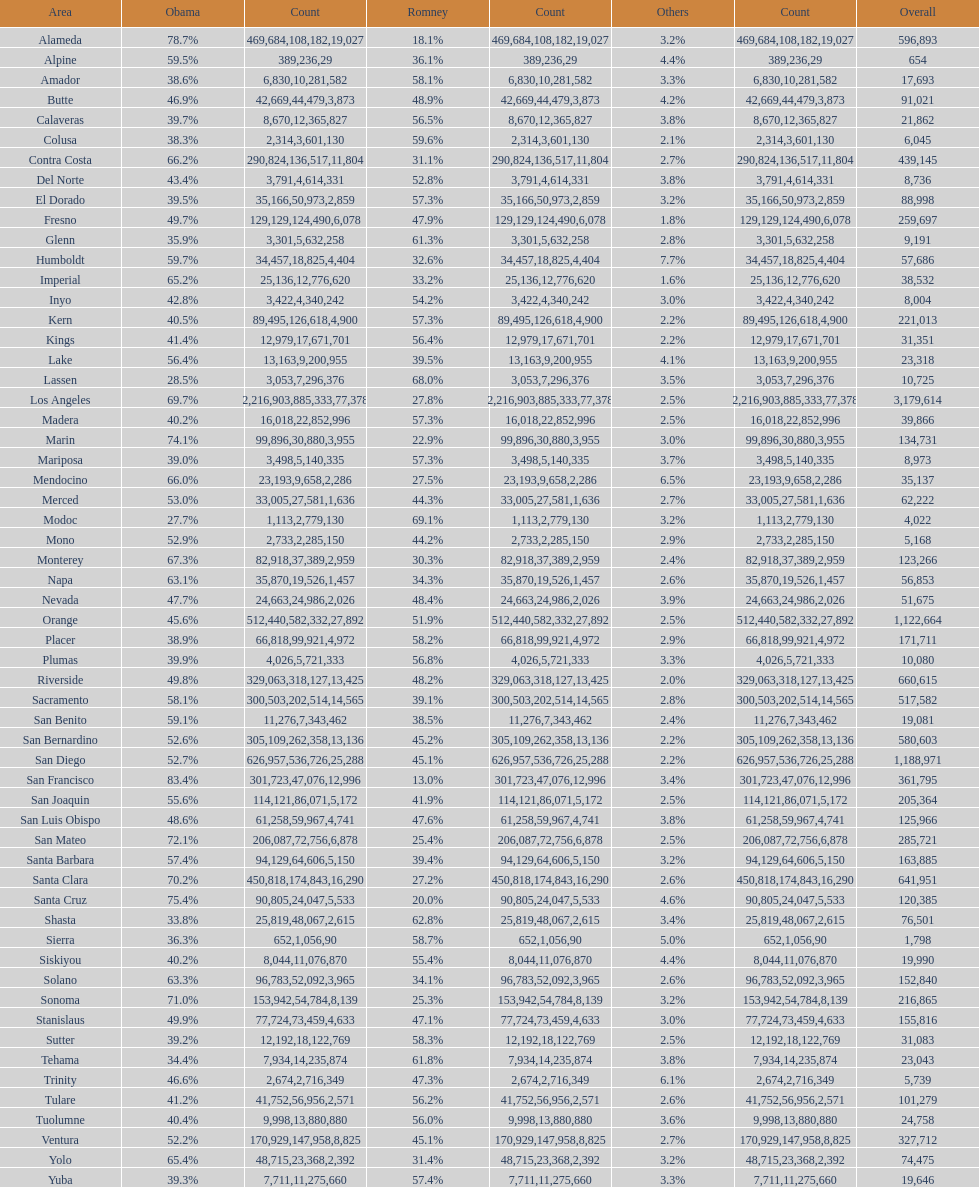What is the total number of votes for amador? 17693. 